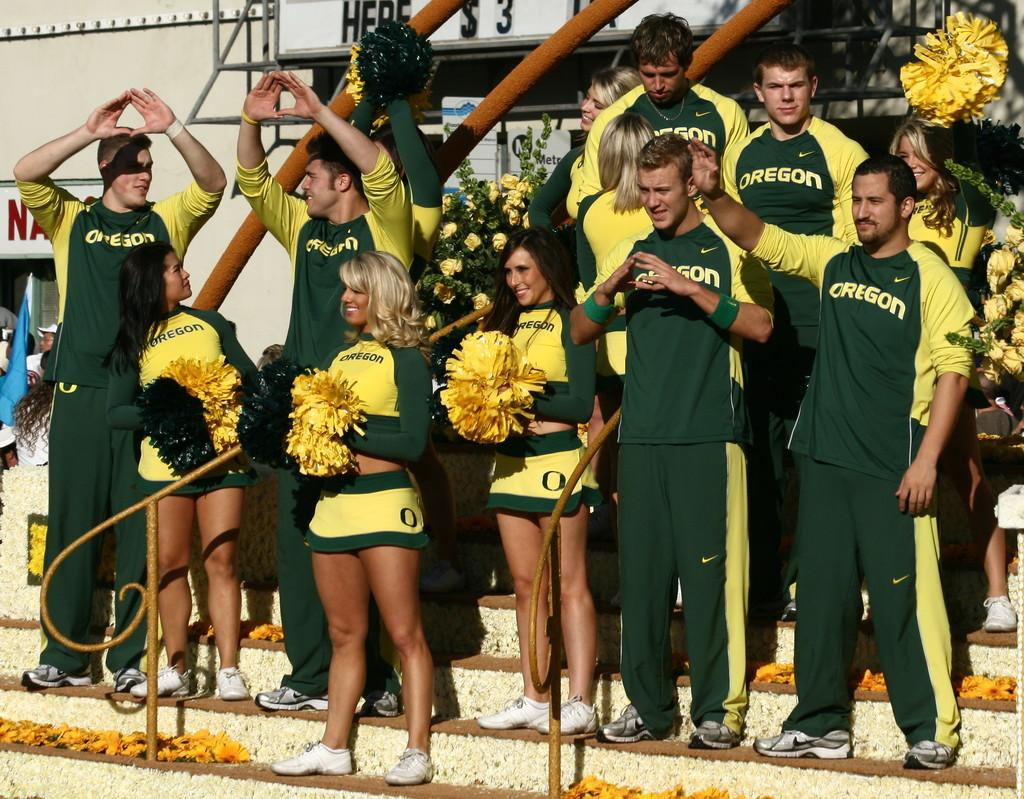<image>
Create a compact narrative representing the image presented. A group of cheerleaders consisting of men and women are wearing matching shirts that say Oregon. 